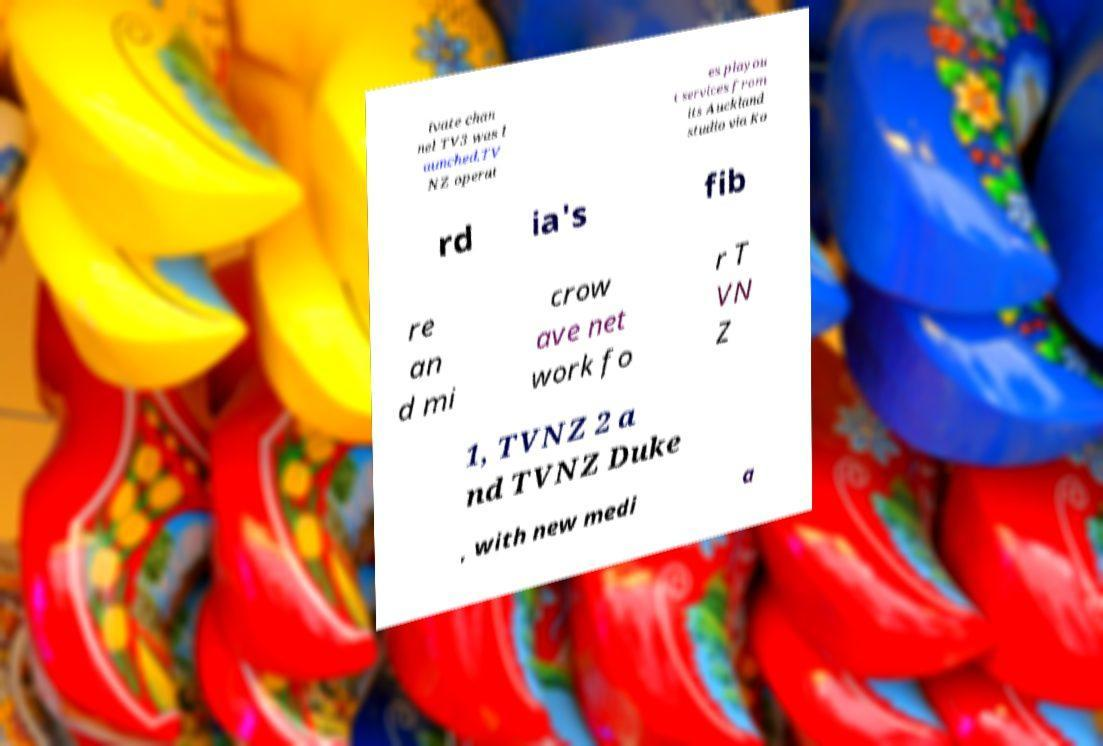There's text embedded in this image that I need extracted. Can you transcribe it verbatim? ivate chan nel TV3 was l aunched.TV NZ operat es playou t services from its Auckland studio via Ko rd ia's fib re an d mi crow ave net work fo r T VN Z 1, TVNZ 2 a nd TVNZ Duke , with new medi a 